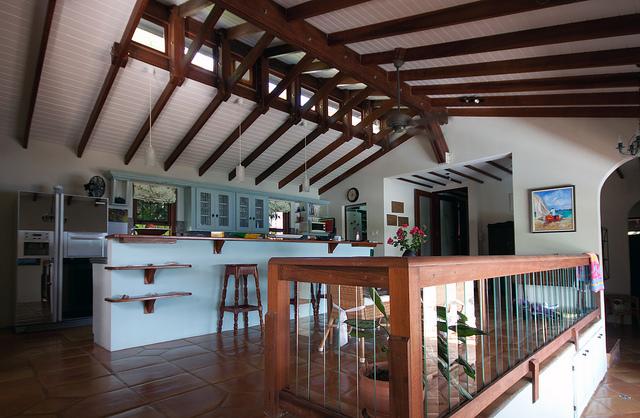What kind of room is this?
Answer briefly. Kitchen. What is the bench made of?
Short answer required. Wood. Is it a kitchen?
Keep it brief. Yes. Is there a fire extinguisher on the wall?
Give a very brief answer. No. Is there a tree in the image?
Short answer required. No. Is this a home kitchen?
Be succinct. Yes. Is there any paintings in the picture?
Quick response, please. Yes. Where are the pumpkins located?
Concise answer only. Counter. What is the floor made of?
Give a very brief answer. Tile. Are there any people in the room?
Keep it brief. No. What is this place called?
Answer briefly. Kitchen. How many chefs are there?
Concise answer only. 0. 